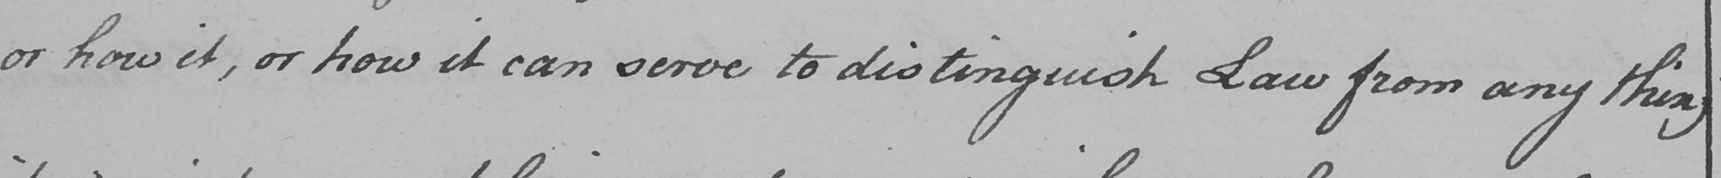What is written in this line of handwriting? or how it , or how it can serve to distinguish Law from any thing 